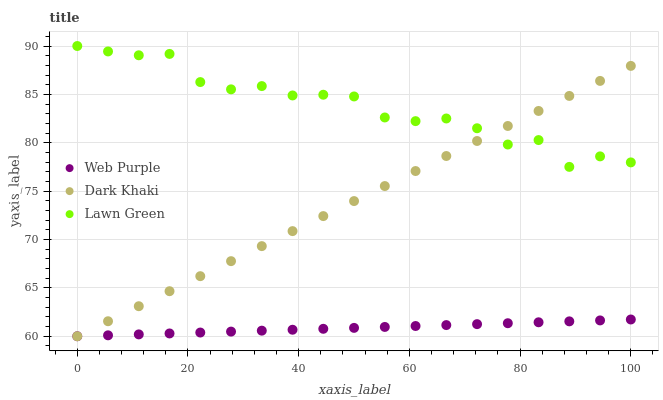Does Web Purple have the minimum area under the curve?
Answer yes or no. Yes. Does Lawn Green have the maximum area under the curve?
Answer yes or no. Yes. Does Lawn Green have the minimum area under the curve?
Answer yes or no. No. Does Web Purple have the maximum area under the curve?
Answer yes or no. No. Is Web Purple the smoothest?
Answer yes or no. Yes. Is Lawn Green the roughest?
Answer yes or no. Yes. Is Lawn Green the smoothest?
Answer yes or no. No. Is Web Purple the roughest?
Answer yes or no. No. Does Dark Khaki have the lowest value?
Answer yes or no. Yes. Does Lawn Green have the lowest value?
Answer yes or no. No. Does Lawn Green have the highest value?
Answer yes or no. Yes. Does Web Purple have the highest value?
Answer yes or no. No. Is Web Purple less than Lawn Green?
Answer yes or no. Yes. Is Lawn Green greater than Web Purple?
Answer yes or no. Yes. Does Lawn Green intersect Dark Khaki?
Answer yes or no. Yes. Is Lawn Green less than Dark Khaki?
Answer yes or no. No. Is Lawn Green greater than Dark Khaki?
Answer yes or no. No. Does Web Purple intersect Lawn Green?
Answer yes or no. No. 